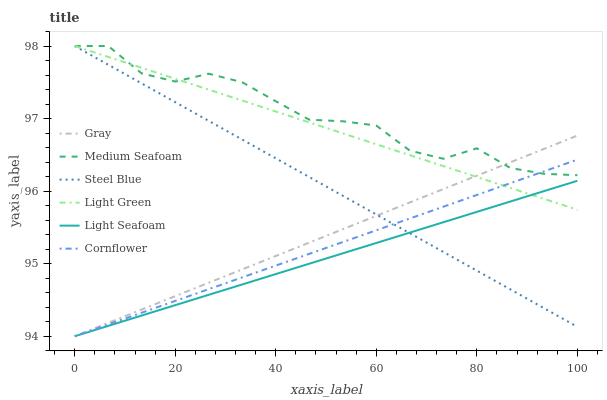Does Light Seafoam have the minimum area under the curve?
Answer yes or no. Yes. Does Medium Seafoam have the maximum area under the curve?
Answer yes or no. Yes. Does Gray have the minimum area under the curve?
Answer yes or no. No. Does Gray have the maximum area under the curve?
Answer yes or no. No. Is Light Green the smoothest?
Answer yes or no. Yes. Is Medium Seafoam the roughest?
Answer yes or no. Yes. Is Gray the smoothest?
Answer yes or no. No. Is Gray the roughest?
Answer yes or no. No. Does Cornflower have the lowest value?
Answer yes or no. Yes. Does Steel Blue have the lowest value?
Answer yes or no. No. Does Medium Seafoam have the highest value?
Answer yes or no. Yes. Does Gray have the highest value?
Answer yes or no. No. Is Light Seafoam less than Medium Seafoam?
Answer yes or no. Yes. Is Medium Seafoam greater than Light Seafoam?
Answer yes or no. Yes. Does Light Seafoam intersect Steel Blue?
Answer yes or no. Yes. Is Light Seafoam less than Steel Blue?
Answer yes or no. No. Is Light Seafoam greater than Steel Blue?
Answer yes or no. No. Does Light Seafoam intersect Medium Seafoam?
Answer yes or no. No. 